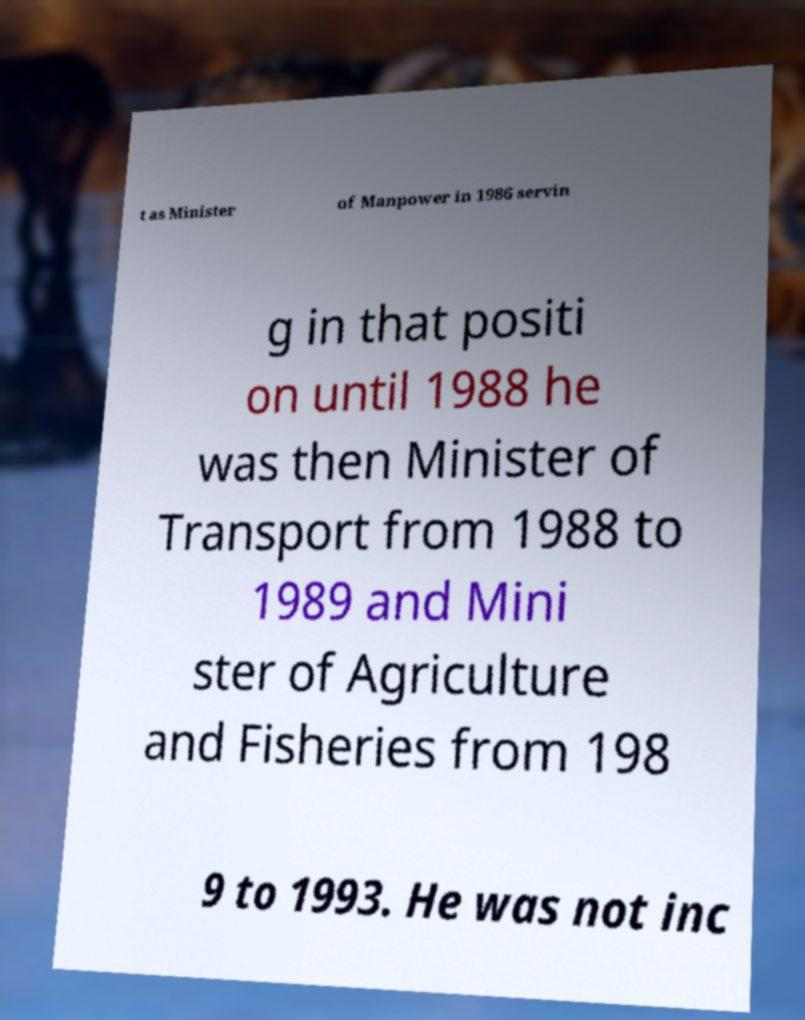Please read and relay the text visible in this image. What does it say? t as Minister of Manpower in 1986 servin g in that positi on until 1988 he was then Minister of Transport from 1988 to 1989 and Mini ster of Agriculture and Fisheries from 198 9 to 1993. He was not inc 